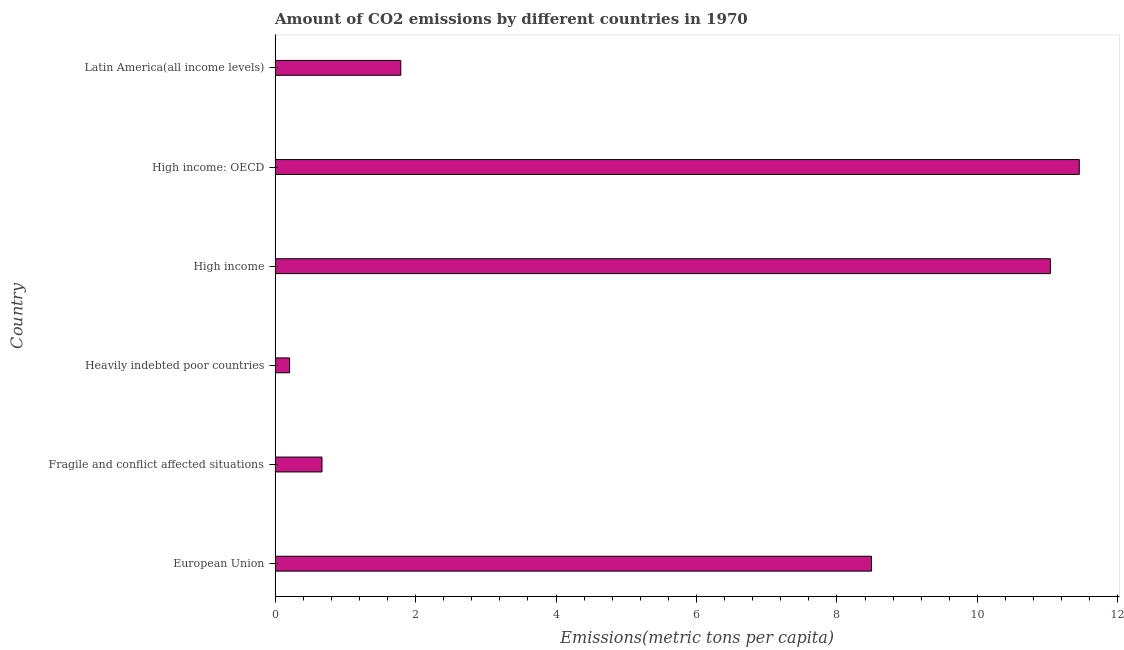What is the title of the graph?
Your response must be concise. Amount of CO2 emissions by different countries in 1970. What is the label or title of the X-axis?
Offer a terse response. Emissions(metric tons per capita). What is the label or title of the Y-axis?
Give a very brief answer. Country. What is the amount of co2 emissions in High income?
Make the answer very short. 11.04. Across all countries, what is the maximum amount of co2 emissions?
Offer a very short reply. 11.45. Across all countries, what is the minimum amount of co2 emissions?
Ensure brevity in your answer.  0.21. In which country was the amount of co2 emissions maximum?
Make the answer very short. High income: OECD. In which country was the amount of co2 emissions minimum?
Your response must be concise. Heavily indebted poor countries. What is the sum of the amount of co2 emissions?
Give a very brief answer. 33.64. What is the difference between the amount of co2 emissions in High income and Latin America(all income levels)?
Give a very brief answer. 9.25. What is the average amount of co2 emissions per country?
Make the answer very short. 5.61. What is the median amount of co2 emissions?
Ensure brevity in your answer.  5.14. What is the ratio of the amount of co2 emissions in Heavily indebted poor countries to that in High income: OECD?
Your answer should be very brief. 0.02. Is the amount of co2 emissions in Heavily indebted poor countries less than that in High income?
Give a very brief answer. Yes. What is the difference between the highest and the second highest amount of co2 emissions?
Your response must be concise. 0.41. Is the sum of the amount of co2 emissions in European Union and Latin America(all income levels) greater than the maximum amount of co2 emissions across all countries?
Make the answer very short. No. What is the difference between the highest and the lowest amount of co2 emissions?
Ensure brevity in your answer.  11.24. In how many countries, is the amount of co2 emissions greater than the average amount of co2 emissions taken over all countries?
Give a very brief answer. 3. Are all the bars in the graph horizontal?
Give a very brief answer. Yes. How many countries are there in the graph?
Your answer should be very brief. 6. Are the values on the major ticks of X-axis written in scientific E-notation?
Your answer should be compact. No. What is the Emissions(metric tons per capita) in European Union?
Provide a succinct answer. 8.49. What is the Emissions(metric tons per capita) in Fragile and conflict affected situations?
Ensure brevity in your answer.  0.67. What is the Emissions(metric tons per capita) in Heavily indebted poor countries?
Ensure brevity in your answer.  0.21. What is the Emissions(metric tons per capita) in High income?
Your response must be concise. 11.04. What is the Emissions(metric tons per capita) of High income: OECD?
Your response must be concise. 11.45. What is the Emissions(metric tons per capita) in Latin America(all income levels)?
Your answer should be very brief. 1.79. What is the difference between the Emissions(metric tons per capita) in European Union and Fragile and conflict affected situations?
Make the answer very short. 7.82. What is the difference between the Emissions(metric tons per capita) in European Union and Heavily indebted poor countries?
Offer a terse response. 8.29. What is the difference between the Emissions(metric tons per capita) in European Union and High income?
Offer a terse response. -2.55. What is the difference between the Emissions(metric tons per capita) in European Union and High income: OECD?
Offer a terse response. -2.96. What is the difference between the Emissions(metric tons per capita) in European Union and Latin America(all income levels)?
Provide a succinct answer. 6.7. What is the difference between the Emissions(metric tons per capita) in Fragile and conflict affected situations and Heavily indebted poor countries?
Your answer should be compact. 0.46. What is the difference between the Emissions(metric tons per capita) in Fragile and conflict affected situations and High income?
Give a very brief answer. -10.37. What is the difference between the Emissions(metric tons per capita) in Fragile and conflict affected situations and High income: OECD?
Your answer should be compact. -10.78. What is the difference between the Emissions(metric tons per capita) in Fragile and conflict affected situations and Latin America(all income levels)?
Give a very brief answer. -1.12. What is the difference between the Emissions(metric tons per capita) in Heavily indebted poor countries and High income?
Offer a terse response. -10.83. What is the difference between the Emissions(metric tons per capita) in Heavily indebted poor countries and High income: OECD?
Offer a terse response. -11.24. What is the difference between the Emissions(metric tons per capita) in Heavily indebted poor countries and Latin America(all income levels)?
Give a very brief answer. -1.58. What is the difference between the Emissions(metric tons per capita) in High income and High income: OECD?
Your answer should be very brief. -0.41. What is the difference between the Emissions(metric tons per capita) in High income and Latin America(all income levels)?
Offer a terse response. 9.25. What is the difference between the Emissions(metric tons per capita) in High income: OECD and Latin America(all income levels)?
Keep it short and to the point. 9.66. What is the ratio of the Emissions(metric tons per capita) in European Union to that in Fragile and conflict affected situations?
Provide a short and direct response. 12.71. What is the ratio of the Emissions(metric tons per capita) in European Union to that in Heavily indebted poor countries?
Your response must be concise. 41.13. What is the ratio of the Emissions(metric tons per capita) in European Union to that in High income?
Your answer should be compact. 0.77. What is the ratio of the Emissions(metric tons per capita) in European Union to that in High income: OECD?
Provide a succinct answer. 0.74. What is the ratio of the Emissions(metric tons per capita) in European Union to that in Latin America(all income levels)?
Provide a succinct answer. 4.75. What is the ratio of the Emissions(metric tons per capita) in Fragile and conflict affected situations to that in Heavily indebted poor countries?
Provide a short and direct response. 3.23. What is the ratio of the Emissions(metric tons per capita) in Fragile and conflict affected situations to that in High income?
Ensure brevity in your answer.  0.06. What is the ratio of the Emissions(metric tons per capita) in Fragile and conflict affected situations to that in High income: OECD?
Provide a succinct answer. 0.06. What is the ratio of the Emissions(metric tons per capita) in Fragile and conflict affected situations to that in Latin America(all income levels)?
Make the answer very short. 0.37. What is the ratio of the Emissions(metric tons per capita) in Heavily indebted poor countries to that in High income?
Provide a short and direct response. 0.02. What is the ratio of the Emissions(metric tons per capita) in Heavily indebted poor countries to that in High income: OECD?
Offer a very short reply. 0.02. What is the ratio of the Emissions(metric tons per capita) in Heavily indebted poor countries to that in Latin America(all income levels)?
Offer a very short reply. 0.12. What is the ratio of the Emissions(metric tons per capita) in High income to that in Latin America(all income levels)?
Ensure brevity in your answer.  6.17. What is the ratio of the Emissions(metric tons per capita) in High income: OECD to that in Latin America(all income levels)?
Offer a terse response. 6.4. 